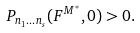<formula> <loc_0><loc_0><loc_500><loc_500>P _ { n _ { 1 } \dots n _ { s } } ( F ^ { M ^ { \ast } } , 0 ) > 0 .</formula> 